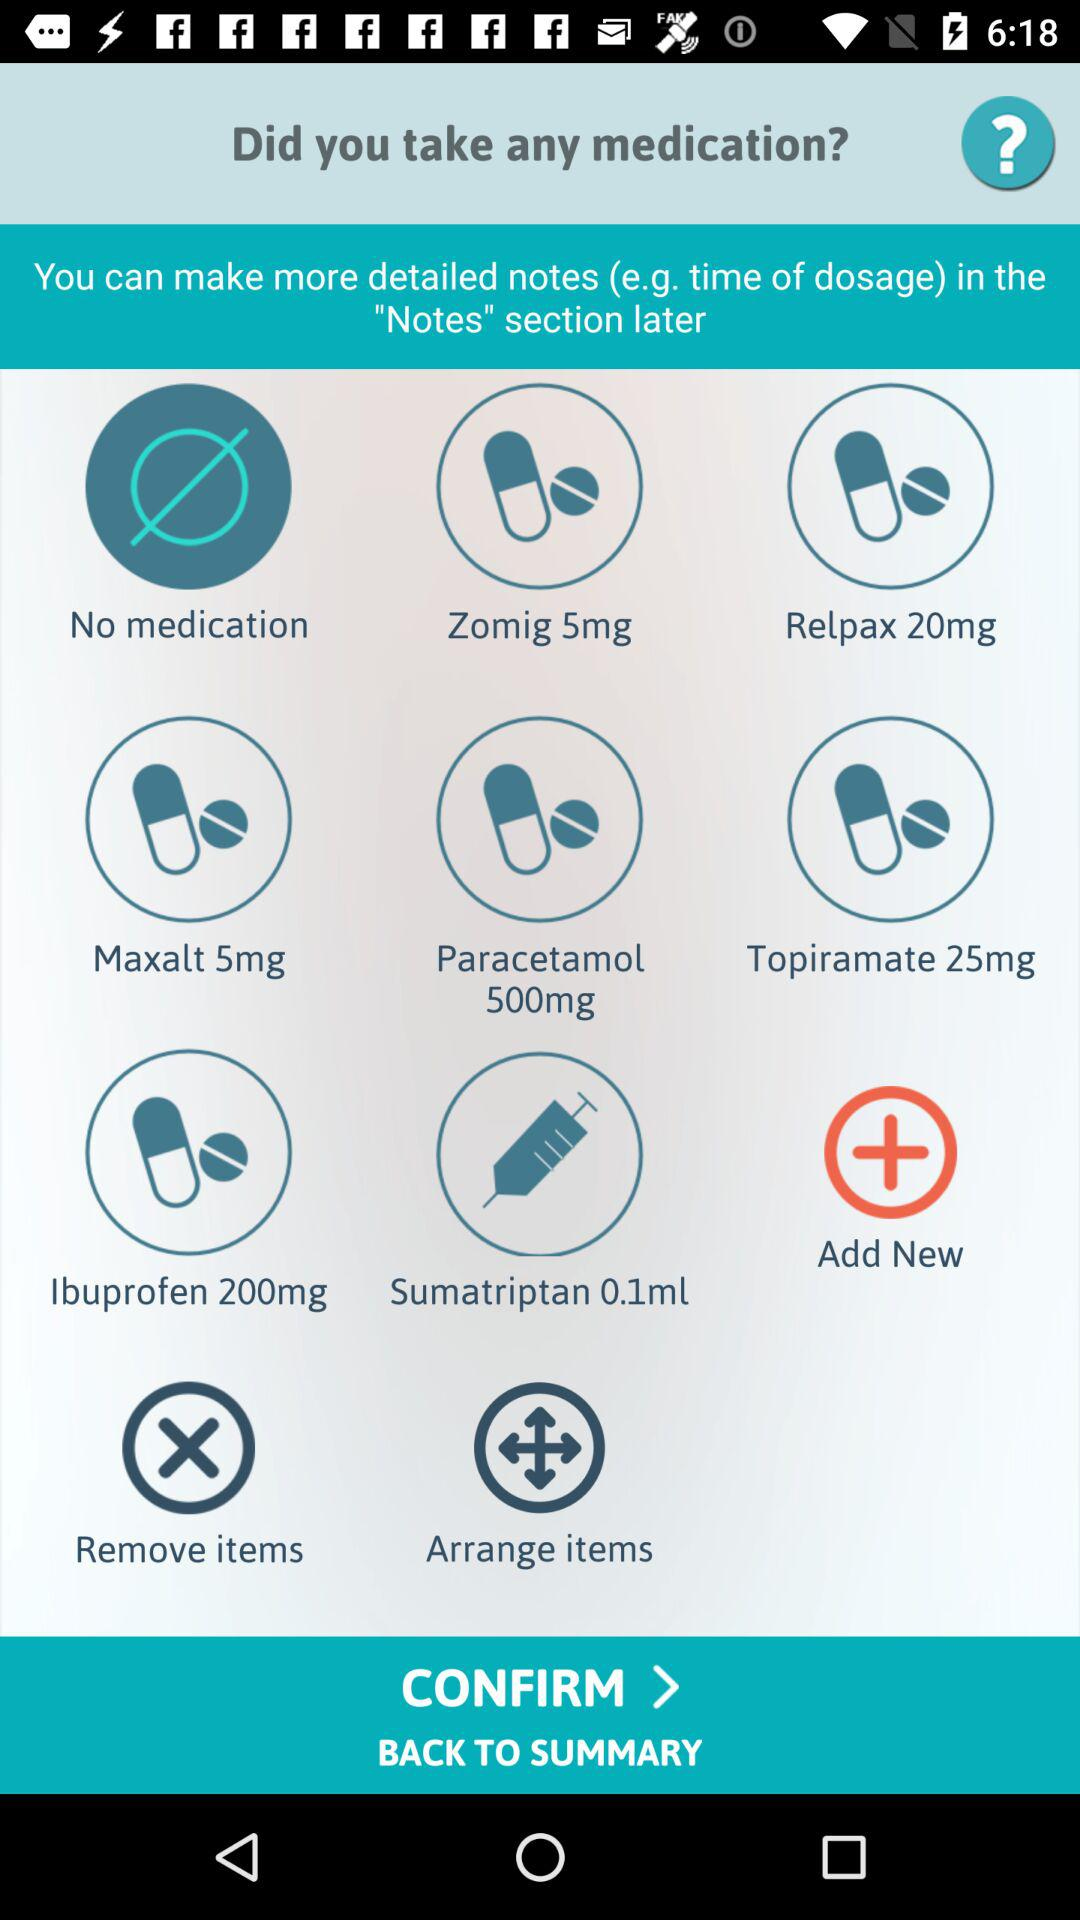What are the added medications in the list? The added medications in the list are "Zomig 5mg", "Relpax 20mg", "Maxalt 5mg", "Paracetamol 500mg", "Topiramate 25mg", "Ibuprofen 200mg" and "Sumatriptan 0.1ml". 